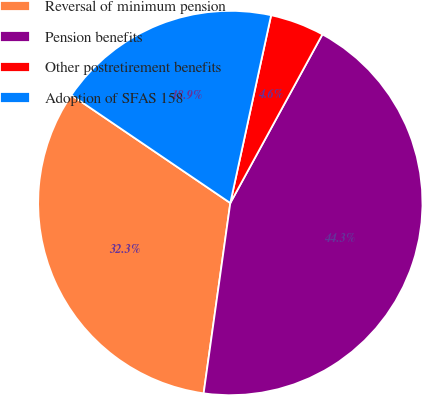<chart> <loc_0><loc_0><loc_500><loc_500><pie_chart><fcel>Reversal of minimum pension<fcel>Pension benefits<fcel>Other postretirement benefits<fcel>Adoption of SFAS 158<nl><fcel>32.28%<fcel>44.26%<fcel>4.55%<fcel>18.91%<nl></chart> 